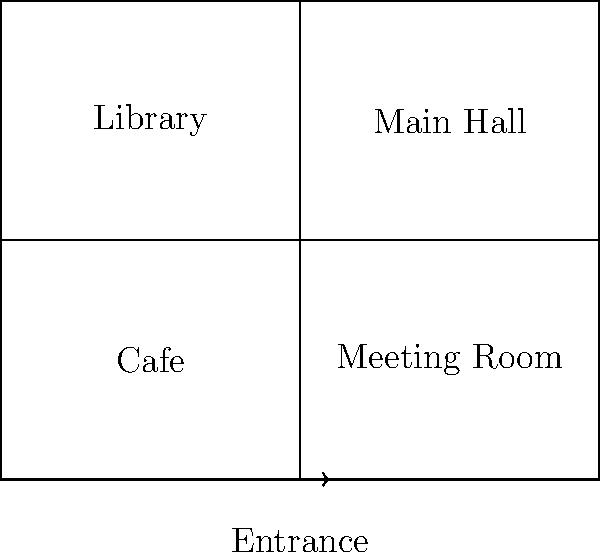Based on the floor plan of the proposed community center in Stroivka, which area is located directly to the right of the Library? To answer this question, let's analyze the floor plan step-by-step:

1. First, identify the Library on the floor plan. It's located in the upper-left quadrant of the building.

2. The Library occupies the left half of the upper section of the building.

3. To find what's directly to the right of the Library, we need to look at the area adjacent to it on its right side.

4. The area to the right of the Library, occupying the right half of the upper section, is labeled "Main Hall".

5. Therefore, the area directly to the right of the Library is the Main Hall.

This layout suggests that the community center is designed to have a spacious main area (the Main Hall) next to a quieter reading space (the Library), which is a common and practical design choice for multi-purpose community buildings.
Answer: Main Hall 